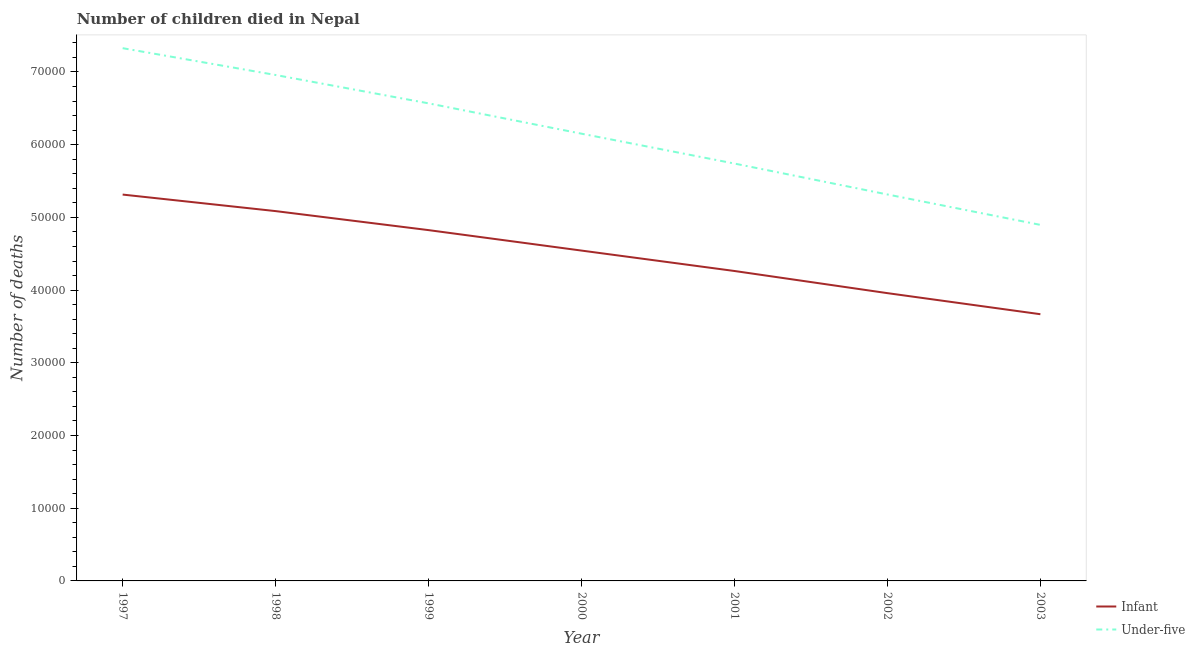Is the number of lines equal to the number of legend labels?
Ensure brevity in your answer.  Yes. What is the number of under-five deaths in 2002?
Your answer should be very brief. 5.32e+04. Across all years, what is the maximum number of infant deaths?
Make the answer very short. 5.31e+04. Across all years, what is the minimum number of infant deaths?
Provide a succinct answer. 3.67e+04. In which year was the number of infant deaths maximum?
Provide a succinct answer. 1997. In which year was the number of under-five deaths minimum?
Your answer should be compact. 2003. What is the total number of under-five deaths in the graph?
Your answer should be very brief. 4.30e+05. What is the difference between the number of infant deaths in 1997 and that in 2001?
Your response must be concise. 1.05e+04. What is the difference between the number of under-five deaths in 1999 and the number of infant deaths in 2003?
Your answer should be compact. 2.90e+04. What is the average number of under-five deaths per year?
Provide a short and direct response. 6.14e+04. In the year 2001, what is the difference between the number of infant deaths and number of under-five deaths?
Provide a succinct answer. -1.48e+04. In how many years, is the number of infant deaths greater than 8000?
Your answer should be very brief. 7. What is the ratio of the number of infant deaths in 1998 to that in 2003?
Provide a succinct answer. 1.39. What is the difference between the highest and the second highest number of infant deaths?
Ensure brevity in your answer.  2274. What is the difference between the highest and the lowest number of under-five deaths?
Give a very brief answer. 2.43e+04. Is the sum of the number of infant deaths in 1997 and 2003 greater than the maximum number of under-five deaths across all years?
Your answer should be compact. Yes. Does the number of under-five deaths monotonically increase over the years?
Ensure brevity in your answer.  No. Is the number of under-five deaths strictly greater than the number of infant deaths over the years?
Ensure brevity in your answer.  Yes. How many lines are there?
Your response must be concise. 2. What is the difference between two consecutive major ticks on the Y-axis?
Offer a terse response. 10000. Does the graph contain grids?
Your answer should be compact. No. How many legend labels are there?
Make the answer very short. 2. How are the legend labels stacked?
Your response must be concise. Vertical. What is the title of the graph?
Offer a terse response. Number of children died in Nepal. Does "Passenger Transport Items" appear as one of the legend labels in the graph?
Your response must be concise. No. What is the label or title of the X-axis?
Give a very brief answer. Year. What is the label or title of the Y-axis?
Provide a short and direct response. Number of deaths. What is the Number of deaths in Infant in 1997?
Provide a short and direct response. 5.31e+04. What is the Number of deaths in Under-five in 1997?
Make the answer very short. 7.33e+04. What is the Number of deaths of Infant in 1998?
Provide a short and direct response. 5.09e+04. What is the Number of deaths in Under-five in 1998?
Make the answer very short. 6.96e+04. What is the Number of deaths in Infant in 1999?
Provide a short and direct response. 4.82e+04. What is the Number of deaths in Under-five in 1999?
Your response must be concise. 6.57e+04. What is the Number of deaths in Infant in 2000?
Your answer should be compact. 4.54e+04. What is the Number of deaths of Under-five in 2000?
Offer a very short reply. 6.15e+04. What is the Number of deaths of Infant in 2001?
Offer a very short reply. 4.26e+04. What is the Number of deaths in Under-five in 2001?
Ensure brevity in your answer.  5.74e+04. What is the Number of deaths of Infant in 2002?
Provide a succinct answer. 3.96e+04. What is the Number of deaths of Under-five in 2002?
Provide a short and direct response. 5.32e+04. What is the Number of deaths in Infant in 2003?
Offer a very short reply. 3.67e+04. What is the Number of deaths in Under-five in 2003?
Ensure brevity in your answer.  4.90e+04. Across all years, what is the maximum Number of deaths of Infant?
Give a very brief answer. 5.31e+04. Across all years, what is the maximum Number of deaths of Under-five?
Your answer should be compact. 7.33e+04. Across all years, what is the minimum Number of deaths of Infant?
Ensure brevity in your answer.  3.67e+04. Across all years, what is the minimum Number of deaths in Under-five?
Provide a succinct answer. 4.90e+04. What is the total Number of deaths of Infant in the graph?
Your answer should be compact. 3.17e+05. What is the total Number of deaths in Under-five in the graph?
Your answer should be compact. 4.30e+05. What is the difference between the Number of deaths of Infant in 1997 and that in 1998?
Keep it short and to the point. 2274. What is the difference between the Number of deaths of Under-five in 1997 and that in 1998?
Offer a terse response. 3689. What is the difference between the Number of deaths in Infant in 1997 and that in 1999?
Your answer should be very brief. 4890. What is the difference between the Number of deaths of Under-five in 1997 and that in 1999?
Provide a short and direct response. 7588. What is the difference between the Number of deaths of Infant in 1997 and that in 2000?
Ensure brevity in your answer.  7704. What is the difference between the Number of deaths of Under-five in 1997 and that in 2000?
Provide a succinct answer. 1.18e+04. What is the difference between the Number of deaths in Infant in 1997 and that in 2001?
Your response must be concise. 1.05e+04. What is the difference between the Number of deaths in Under-five in 1997 and that in 2001?
Keep it short and to the point. 1.59e+04. What is the difference between the Number of deaths in Infant in 1997 and that in 2002?
Offer a terse response. 1.36e+04. What is the difference between the Number of deaths in Under-five in 1997 and that in 2002?
Keep it short and to the point. 2.01e+04. What is the difference between the Number of deaths of Infant in 1997 and that in 2003?
Offer a very short reply. 1.65e+04. What is the difference between the Number of deaths in Under-five in 1997 and that in 2003?
Provide a short and direct response. 2.43e+04. What is the difference between the Number of deaths of Infant in 1998 and that in 1999?
Provide a short and direct response. 2616. What is the difference between the Number of deaths of Under-five in 1998 and that in 1999?
Offer a very short reply. 3899. What is the difference between the Number of deaths of Infant in 1998 and that in 2000?
Your answer should be compact. 5430. What is the difference between the Number of deaths of Under-five in 1998 and that in 2000?
Provide a short and direct response. 8072. What is the difference between the Number of deaths in Infant in 1998 and that in 2001?
Your answer should be compact. 8238. What is the difference between the Number of deaths of Under-five in 1998 and that in 2001?
Your response must be concise. 1.22e+04. What is the difference between the Number of deaths in Infant in 1998 and that in 2002?
Offer a terse response. 1.13e+04. What is the difference between the Number of deaths in Under-five in 1998 and that in 2002?
Offer a terse response. 1.64e+04. What is the difference between the Number of deaths of Infant in 1998 and that in 2003?
Keep it short and to the point. 1.42e+04. What is the difference between the Number of deaths of Under-five in 1998 and that in 2003?
Make the answer very short. 2.06e+04. What is the difference between the Number of deaths of Infant in 1999 and that in 2000?
Your answer should be very brief. 2814. What is the difference between the Number of deaths in Under-five in 1999 and that in 2000?
Your answer should be compact. 4173. What is the difference between the Number of deaths in Infant in 1999 and that in 2001?
Provide a succinct answer. 5622. What is the difference between the Number of deaths in Under-five in 1999 and that in 2001?
Keep it short and to the point. 8280. What is the difference between the Number of deaths of Infant in 1999 and that in 2002?
Provide a succinct answer. 8668. What is the difference between the Number of deaths of Under-five in 1999 and that in 2002?
Offer a very short reply. 1.25e+04. What is the difference between the Number of deaths of Infant in 1999 and that in 2003?
Make the answer very short. 1.16e+04. What is the difference between the Number of deaths in Under-five in 1999 and that in 2003?
Provide a succinct answer. 1.67e+04. What is the difference between the Number of deaths of Infant in 2000 and that in 2001?
Ensure brevity in your answer.  2808. What is the difference between the Number of deaths in Under-five in 2000 and that in 2001?
Make the answer very short. 4107. What is the difference between the Number of deaths of Infant in 2000 and that in 2002?
Offer a terse response. 5854. What is the difference between the Number of deaths in Under-five in 2000 and that in 2002?
Your answer should be compact. 8359. What is the difference between the Number of deaths in Infant in 2000 and that in 2003?
Provide a short and direct response. 8752. What is the difference between the Number of deaths of Under-five in 2000 and that in 2003?
Provide a succinct answer. 1.25e+04. What is the difference between the Number of deaths of Infant in 2001 and that in 2002?
Offer a very short reply. 3046. What is the difference between the Number of deaths of Under-five in 2001 and that in 2002?
Give a very brief answer. 4252. What is the difference between the Number of deaths in Infant in 2001 and that in 2003?
Give a very brief answer. 5944. What is the difference between the Number of deaths in Under-five in 2001 and that in 2003?
Provide a short and direct response. 8435. What is the difference between the Number of deaths in Infant in 2002 and that in 2003?
Make the answer very short. 2898. What is the difference between the Number of deaths of Under-five in 2002 and that in 2003?
Make the answer very short. 4183. What is the difference between the Number of deaths in Infant in 1997 and the Number of deaths in Under-five in 1998?
Offer a very short reply. -1.64e+04. What is the difference between the Number of deaths in Infant in 1997 and the Number of deaths in Under-five in 1999?
Provide a succinct answer. -1.25e+04. What is the difference between the Number of deaths in Infant in 1997 and the Number of deaths in Under-five in 2000?
Keep it short and to the point. -8373. What is the difference between the Number of deaths in Infant in 1997 and the Number of deaths in Under-five in 2001?
Your response must be concise. -4266. What is the difference between the Number of deaths in Infant in 1997 and the Number of deaths in Under-five in 2003?
Offer a very short reply. 4169. What is the difference between the Number of deaths of Infant in 1998 and the Number of deaths of Under-five in 1999?
Ensure brevity in your answer.  -1.48e+04. What is the difference between the Number of deaths of Infant in 1998 and the Number of deaths of Under-five in 2000?
Offer a terse response. -1.06e+04. What is the difference between the Number of deaths in Infant in 1998 and the Number of deaths in Under-five in 2001?
Your response must be concise. -6540. What is the difference between the Number of deaths of Infant in 1998 and the Number of deaths of Under-five in 2002?
Offer a very short reply. -2288. What is the difference between the Number of deaths of Infant in 1998 and the Number of deaths of Under-five in 2003?
Keep it short and to the point. 1895. What is the difference between the Number of deaths in Infant in 1999 and the Number of deaths in Under-five in 2000?
Your answer should be compact. -1.33e+04. What is the difference between the Number of deaths of Infant in 1999 and the Number of deaths of Under-five in 2001?
Ensure brevity in your answer.  -9156. What is the difference between the Number of deaths of Infant in 1999 and the Number of deaths of Under-five in 2002?
Make the answer very short. -4904. What is the difference between the Number of deaths of Infant in 1999 and the Number of deaths of Under-five in 2003?
Make the answer very short. -721. What is the difference between the Number of deaths of Infant in 2000 and the Number of deaths of Under-five in 2001?
Provide a succinct answer. -1.20e+04. What is the difference between the Number of deaths in Infant in 2000 and the Number of deaths in Under-five in 2002?
Give a very brief answer. -7718. What is the difference between the Number of deaths in Infant in 2000 and the Number of deaths in Under-five in 2003?
Offer a terse response. -3535. What is the difference between the Number of deaths in Infant in 2001 and the Number of deaths in Under-five in 2002?
Ensure brevity in your answer.  -1.05e+04. What is the difference between the Number of deaths in Infant in 2001 and the Number of deaths in Under-five in 2003?
Offer a very short reply. -6343. What is the difference between the Number of deaths in Infant in 2002 and the Number of deaths in Under-five in 2003?
Offer a very short reply. -9389. What is the average Number of deaths in Infant per year?
Ensure brevity in your answer.  4.52e+04. What is the average Number of deaths in Under-five per year?
Give a very brief answer. 6.14e+04. In the year 1997, what is the difference between the Number of deaths of Infant and Number of deaths of Under-five?
Make the answer very short. -2.01e+04. In the year 1998, what is the difference between the Number of deaths of Infant and Number of deaths of Under-five?
Ensure brevity in your answer.  -1.87e+04. In the year 1999, what is the difference between the Number of deaths of Infant and Number of deaths of Under-five?
Keep it short and to the point. -1.74e+04. In the year 2000, what is the difference between the Number of deaths of Infant and Number of deaths of Under-five?
Ensure brevity in your answer.  -1.61e+04. In the year 2001, what is the difference between the Number of deaths of Infant and Number of deaths of Under-five?
Offer a terse response. -1.48e+04. In the year 2002, what is the difference between the Number of deaths of Infant and Number of deaths of Under-five?
Give a very brief answer. -1.36e+04. In the year 2003, what is the difference between the Number of deaths in Infant and Number of deaths in Under-five?
Your answer should be very brief. -1.23e+04. What is the ratio of the Number of deaths of Infant in 1997 to that in 1998?
Offer a terse response. 1.04. What is the ratio of the Number of deaths in Under-five in 1997 to that in 1998?
Offer a terse response. 1.05. What is the ratio of the Number of deaths of Infant in 1997 to that in 1999?
Give a very brief answer. 1.1. What is the ratio of the Number of deaths of Under-five in 1997 to that in 1999?
Offer a very short reply. 1.12. What is the ratio of the Number of deaths of Infant in 1997 to that in 2000?
Ensure brevity in your answer.  1.17. What is the ratio of the Number of deaths in Under-five in 1997 to that in 2000?
Your response must be concise. 1.19. What is the ratio of the Number of deaths in Infant in 1997 to that in 2001?
Give a very brief answer. 1.25. What is the ratio of the Number of deaths in Under-five in 1997 to that in 2001?
Provide a succinct answer. 1.28. What is the ratio of the Number of deaths of Infant in 1997 to that in 2002?
Ensure brevity in your answer.  1.34. What is the ratio of the Number of deaths of Under-five in 1997 to that in 2002?
Offer a very short reply. 1.38. What is the ratio of the Number of deaths of Infant in 1997 to that in 2003?
Your answer should be very brief. 1.45. What is the ratio of the Number of deaths of Under-five in 1997 to that in 2003?
Give a very brief answer. 1.5. What is the ratio of the Number of deaths of Infant in 1998 to that in 1999?
Ensure brevity in your answer.  1.05. What is the ratio of the Number of deaths in Under-five in 1998 to that in 1999?
Provide a succinct answer. 1.06. What is the ratio of the Number of deaths of Infant in 1998 to that in 2000?
Offer a terse response. 1.12. What is the ratio of the Number of deaths in Under-five in 1998 to that in 2000?
Make the answer very short. 1.13. What is the ratio of the Number of deaths in Infant in 1998 to that in 2001?
Provide a short and direct response. 1.19. What is the ratio of the Number of deaths of Under-five in 1998 to that in 2001?
Provide a succinct answer. 1.21. What is the ratio of the Number of deaths of Infant in 1998 to that in 2002?
Give a very brief answer. 1.29. What is the ratio of the Number of deaths of Under-five in 1998 to that in 2002?
Give a very brief answer. 1.31. What is the ratio of the Number of deaths of Infant in 1998 to that in 2003?
Give a very brief answer. 1.39. What is the ratio of the Number of deaths in Under-five in 1998 to that in 2003?
Give a very brief answer. 1.42. What is the ratio of the Number of deaths of Infant in 1999 to that in 2000?
Provide a short and direct response. 1.06. What is the ratio of the Number of deaths in Under-five in 1999 to that in 2000?
Keep it short and to the point. 1.07. What is the ratio of the Number of deaths in Infant in 1999 to that in 2001?
Give a very brief answer. 1.13. What is the ratio of the Number of deaths in Under-five in 1999 to that in 2001?
Your answer should be compact. 1.14. What is the ratio of the Number of deaths of Infant in 1999 to that in 2002?
Make the answer very short. 1.22. What is the ratio of the Number of deaths of Under-five in 1999 to that in 2002?
Provide a succinct answer. 1.24. What is the ratio of the Number of deaths of Infant in 1999 to that in 2003?
Your answer should be compact. 1.32. What is the ratio of the Number of deaths of Under-five in 1999 to that in 2003?
Offer a very short reply. 1.34. What is the ratio of the Number of deaths of Infant in 2000 to that in 2001?
Make the answer very short. 1.07. What is the ratio of the Number of deaths in Under-five in 2000 to that in 2001?
Keep it short and to the point. 1.07. What is the ratio of the Number of deaths in Infant in 2000 to that in 2002?
Keep it short and to the point. 1.15. What is the ratio of the Number of deaths in Under-five in 2000 to that in 2002?
Provide a succinct answer. 1.16. What is the ratio of the Number of deaths of Infant in 2000 to that in 2003?
Offer a terse response. 1.24. What is the ratio of the Number of deaths of Under-five in 2000 to that in 2003?
Your response must be concise. 1.26. What is the ratio of the Number of deaths of Infant in 2001 to that in 2002?
Your answer should be compact. 1.08. What is the ratio of the Number of deaths of Under-five in 2001 to that in 2002?
Your answer should be compact. 1.08. What is the ratio of the Number of deaths in Infant in 2001 to that in 2003?
Make the answer very short. 1.16. What is the ratio of the Number of deaths in Under-five in 2001 to that in 2003?
Offer a very short reply. 1.17. What is the ratio of the Number of deaths of Infant in 2002 to that in 2003?
Offer a terse response. 1.08. What is the ratio of the Number of deaths of Under-five in 2002 to that in 2003?
Offer a very short reply. 1.09. What is the difference between the highest and the second highest Number of deaths in Infant?
Provide a succinct answer. 2274. What is the difference between the highest and the second highest Number of deaths of Under-five?
Your answer should be compact. 3689. What is the difference between the highest and the lowest Number of deaths in Infant?
Give a very brief answer. 1.65e+04. What is the difference between the highest and the lowest Number of deaths in Under-five?
Ensure brevity in your answer.  2.43e+04. 